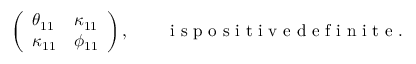Convert formula to latex. <formula><loc_0><loc_0><loc_500><loc_500>\begin{array} { r } { \left ( \begin{array} { l l } { \theta _ { 1 1 } } & { \kappa _ { 1 1 } } \\ { \kappa _ { 1 1 } } & { \phi _ { 1 1 } } \end{array} \right ) , \quad i s p o s i t i v e d e f i n i t e . } \end{array}</formula> 